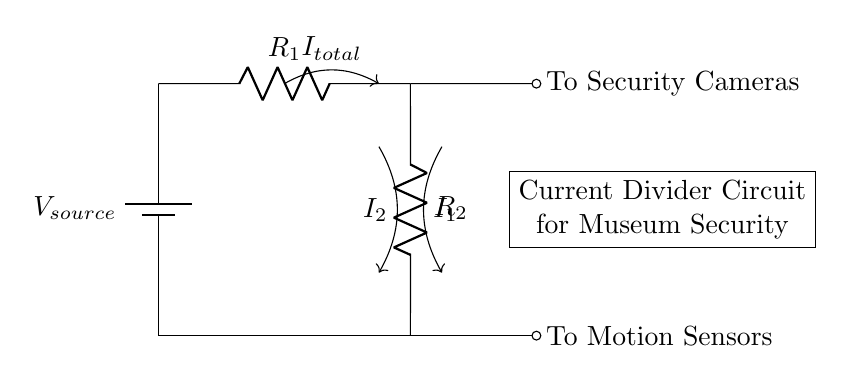What is the type of circuit shown? The circuit is a current divider, which splits the total current into two branches.
Answer: Current Divider What components are present in the circuit? There are a voltage source and two resistors in the circuit.
Answer: Voltage source and resistors How many branches does the current split into? The current splits into two branches, one for security cameras and one for motion sensors.
Answer: Two What is the direction of current flow in the circuit? The current flows from the voltage source through the resistors and to the output branches.
Answer: From source to branches What is the relationship between the resistors in this circuit? The resistors are in parallel, which allows the current to divide between them according to their values.
Answer: Parallel What is the total current entering the circuit? The total current is designated as I total in the diagram.
Answer: I total How does changing the resistance of R1 affect the currents I1 and I2? If R1 decreases, I1 increases while I2 decreases, showing the inverse relationship in a current divider.
Answer: Inversely related 